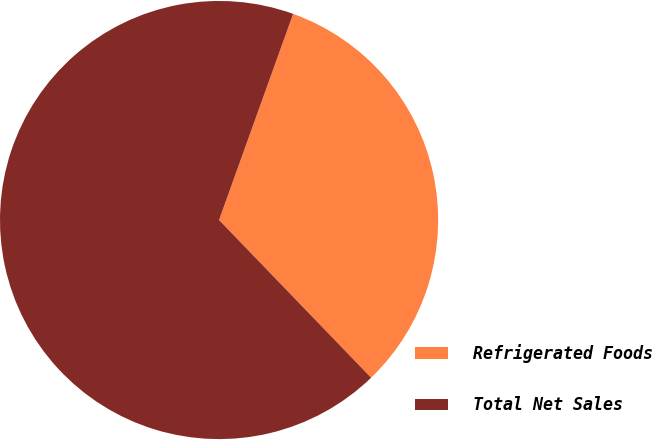Convert chart to OTSL. <chart><loc_0><loc_0><loc_500><loc_500><pie_chart><fcel>Refrigerated Foods<fcel>Total Net Sales<nl><fcel>32.3%<fcel>67.7%<nl></chart> 